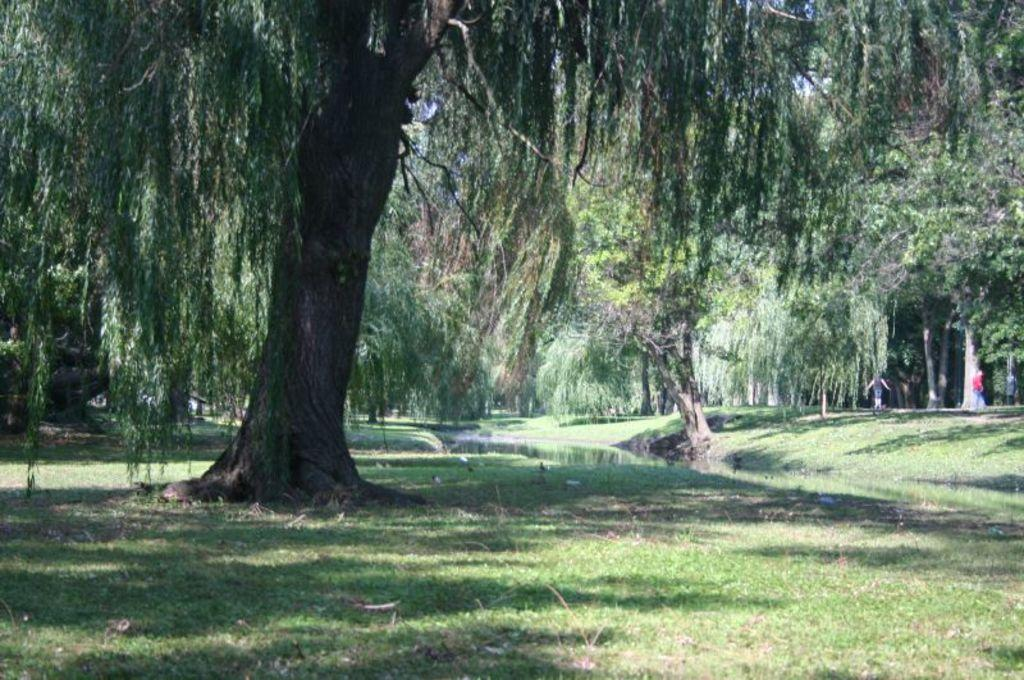What is the main feature of the image? The main feature of the image is the presence of many trees. Can you describe the people in the image? There are people standing on the ground in the image. What can be observed about the clothing of the people? The people are wearing different color dresses. What type of jelly can be seen on the trees in the image? There is no jelly present on the trees in the image; it features many trees and people wearing different color dresses. Can you tell me how many marbles are scattered on the ground in the image? There are no marbles visible on the ground in the image. 